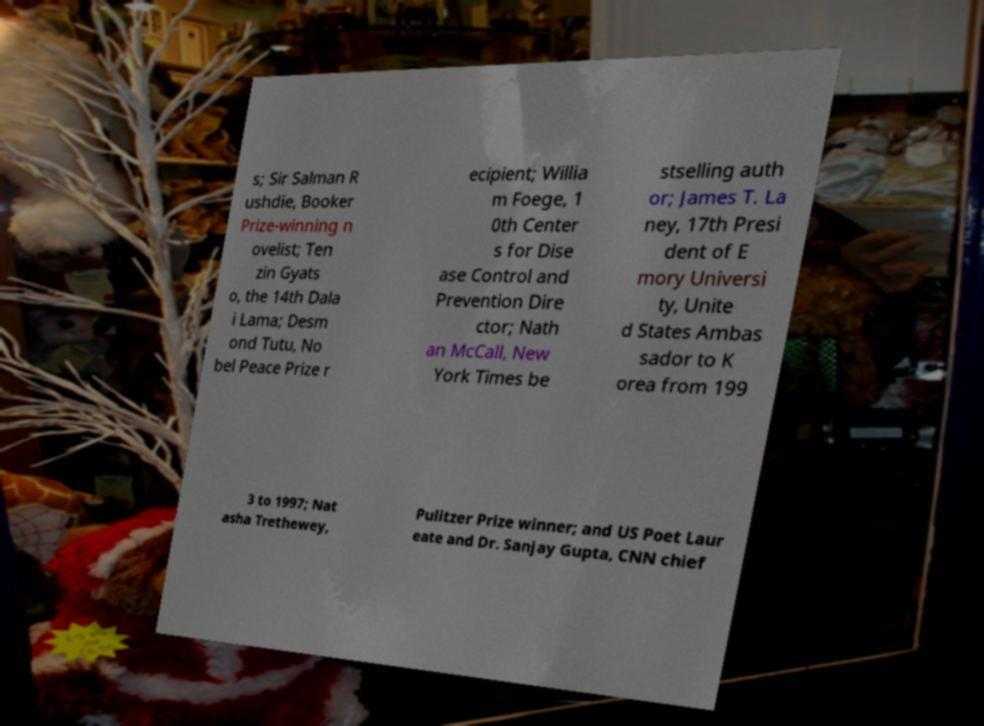What messages or text are displayed in this image? I need them in a readable, typed format. s; Sir Salman R ushdie, Booker Prize-winning n ovelist; Ten zin Gyats o, the 14th Dala i Lama; Desm ond Tutu, No bel Peace Prize r ecipient; Willia m Foege, 1 0th Center s for Dise ase Control and Prevention Dire ctor; Nath an McCall, New York Times be stselling auth or; James T. La ney, 17th Presi dent of E mory Universi ty, Unite d States Ambas sador to K orea from 199 3 to 1997; Nat asha Trethewey, Pulitzer Prize winner; and US Poet Laur eate and Dr. Sanjay Gupta, CNN chief 